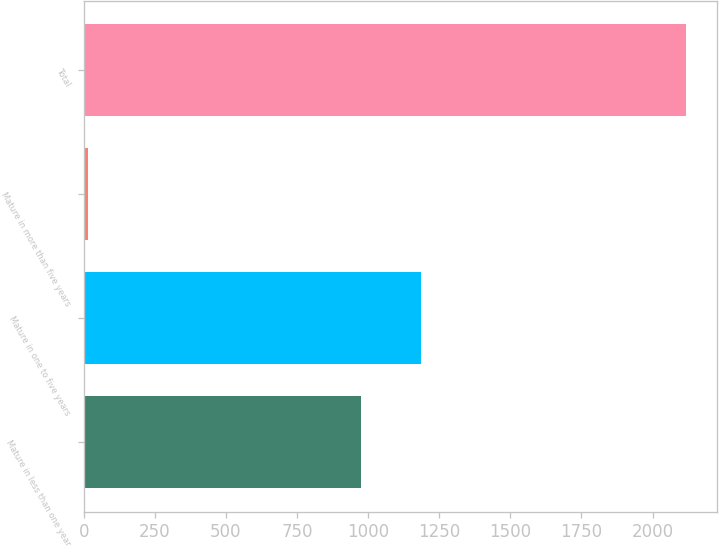Convert chart to OTSL. <chart><loc_0><loc_0><loc_500><loc_500><bar_chart><fcel>Mature in less than one year<fcel>Mature in one to five years<fcel>Mature in more than five years<fcel>Total<nl><fcel>976.7<fcel>1186.98<fcel>16.4<fcel>2119.2<nl></chart> 